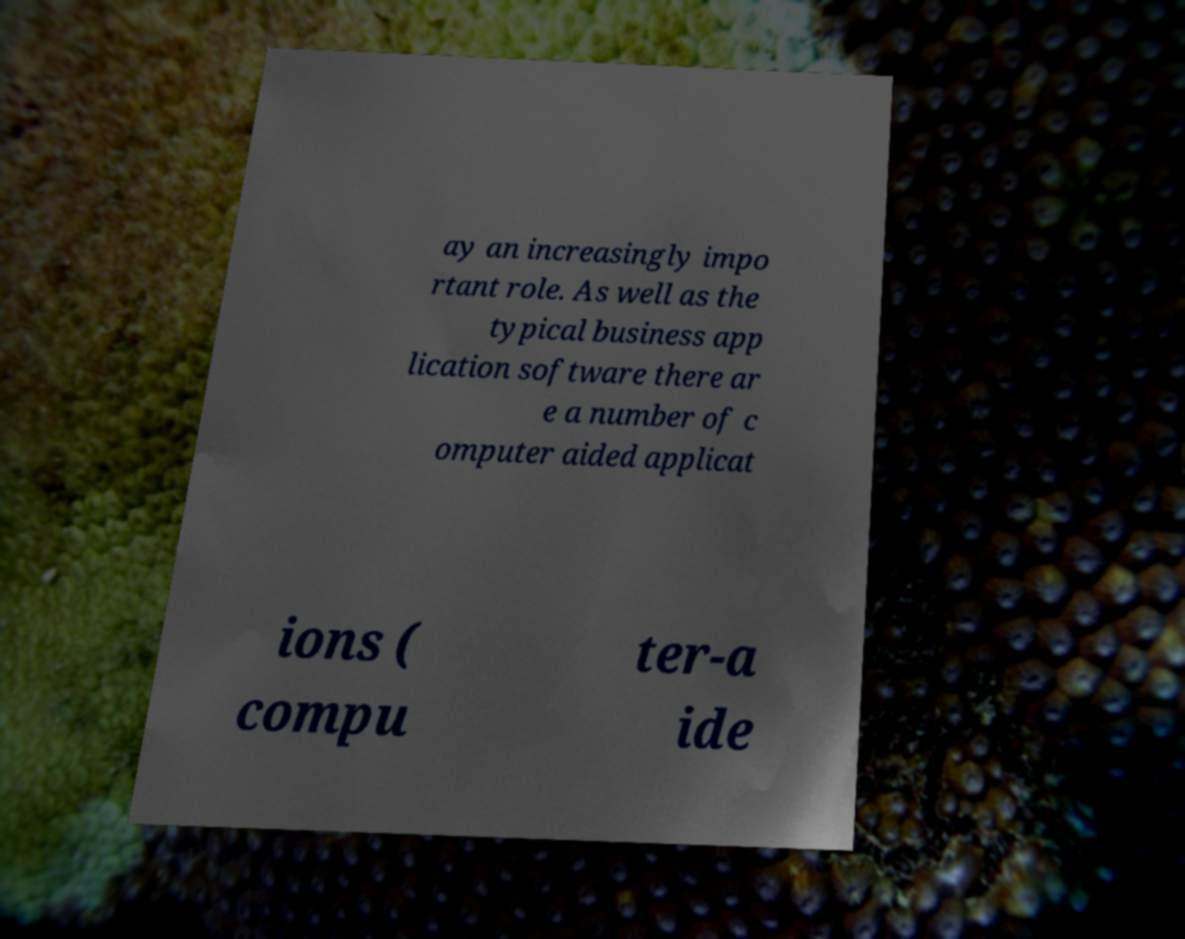I need the written content from this picture converted into text. Can you do that? ay an increasingly impo rtant role. As well as the typical business app lication software there ar e a number of c omputer aided applicat ions ( compu ter-a ide 